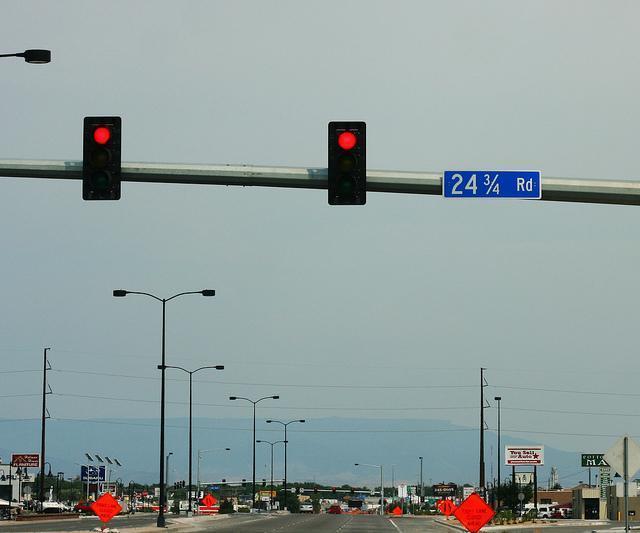How many orange signs are on the street?
Give a very brief answer. 5. How many traffic lights can you see?
Give a very brief answer. 2. How many people are between the two orange buses in the image?
Give a very brief answer. 0. 